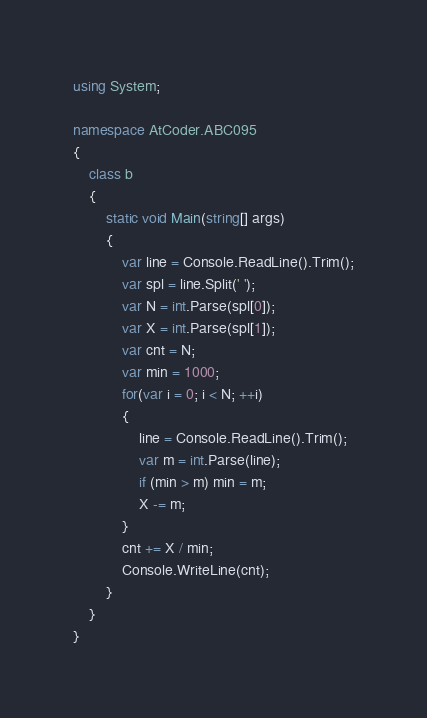<code> <loc_0><loc_0><loc_500><loc_500><_C#_>using System;

namespace AtCoder.ABC095
{
    class b
    {
        static void Main(string[] args)
        {
            var line = Console.ReadLine().Trim();
            var spl = line.Split(' ');
            var N = int.Parse(spl[0]);
            var X = int.Parse(spl[1]);
            var cnt = N;
            var min = 1000;
            for(var i = 0; i < N; ++i)
            {
                line = Console.ReadLine().Trim();
                var m = int.Parse(line);
                if (min > m) min = m;
                X -= m;
            }
            cnt += X / min;
            Console.WriteLine(cnt);
        }
    }
}
</code> 